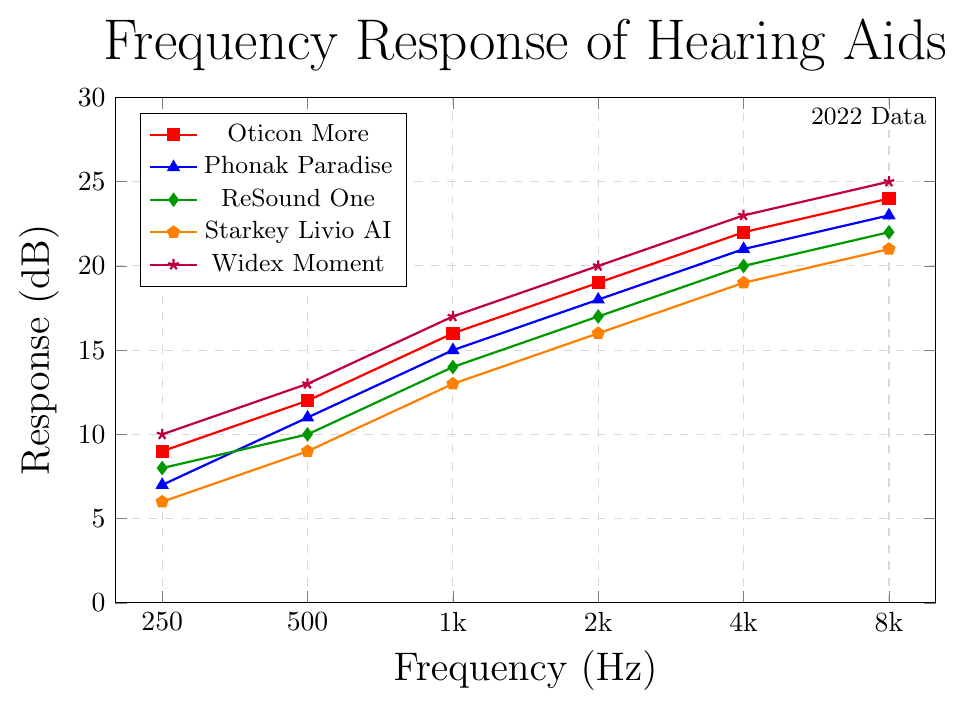What is the response level of the "Widex Moment" model at 2000 Hz? Locate the "Widex Moment" line (purple) on the plot and find the point that corresponds to 2000 Hz on the x-axis. Trace vertically to see the y-axis value.
Answer: 20 dB Which model provides the highest response at 1000 Hz? Compare the response levels of all the models at 1000 Hz by looking at their respective values on the y-axis. The "Widex Moment" (purple) model has the highest value.
Answer: Widex Moment What's the difference in response between "Oticon More" and "Phonak Paradise" at 250 Hz? Identify the response of "Oticon More" (red) at 250 Hz, which is 9 dB, and the response of "Phonak Paradise" (blue), which is 7 dB. Subtract the latter from the former.
Answer: 2 dB What is the average response level of the "Starkey Livio AI" model across all frequencies? Add the response values of the "Starkey Livio AI" (orange) model: (6 + 9 + 13 + 16 + 19 + 21) and divide by the number of data points (6).
Answer: 14 dB At which frequency is the response level of "ReSound One" equal to 17 dB? Trace along the "ReSound One" (green) curve to find the point where the y-axis value is 17 dB. This occurs at 2000 Hz.
Answer: 2000 Hz Which model shows a consistent rising trend across all frequencies? Check each model's response levels across all frequencies to see if they consistently increase. All models show this trend, but "Widex Moment" (purple) consistently rises the most.
Answer: Widex Moment How much does the response of "Phonak Paradise" increase from 250 Hz to 2000 Hz? Find the response level of "Phonak Paradise" (blue) at 250 Hz (7 dB) and at 2000 Hz (18 dB), then subtract 7 from 18.
Answer: 11 dB Which model has the smallest response difference between 4000 Hz and 8000 Hz? Calculate the response difference between 4000 Hz and 8000 Hz for each model and compare. The "Oticon More" (red) model has the smallest difference: 24 - 22 = 2 dB.
Answer: Oticon More 